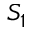Convert formula to latex. <formula><loc_0><loc_0><loc_500><loc_500>S _ { 1 }</formula> 